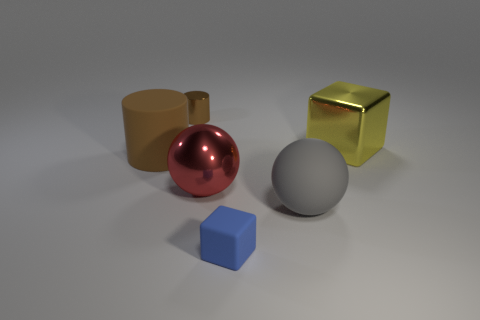Add 4 large purple metal blocks. How many objects exist? 10 Subtract all yellow blocks. How many blocks are left? 1 Subtract all cylinders. How many objects are left? 4 Subtract 2 spheres. How many spheres are left? 0 Subtract 0 blue spheres. How many objects are left? 6 Subtract all gray cylinders. Subtract all red cubes. How many cylinders are left? 2 Subtract all large gray rubber things. Subtract all large shiny things. How many objects are left? 3 Add 1 tiny blue things. How many tiny blue things are left? 2 Add 2 green objects. How many green objects exist? 2 